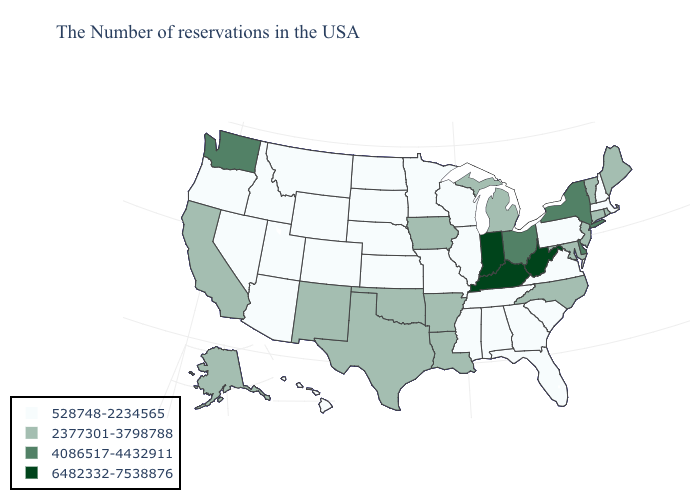How many symbols are there in the legend?
Short answer required. 4. Is the legend a continuous bar?
Write a very short answer. No. Among the states that border Missouri , does Oklahoma have the highest value?
Write a very short answer. No. Does the map have missing data?
Concise answer only. No. Which states have the lowest value in the USA?
Keep it brief. Massachusetts, New Hampshire, Pennsylvania, Virginia, South Carolina, Florida, Georgia, Alabama, Tennessee, Wisconsin, Illinois, Mississippi, Missouri, Minnesota, Kansas, Nebraska, South Dakota, North Dakota, Wyoming, Colorado, Utah, Montana, Arizona, Idaho, Nevada, Oregon, Hawaii. Which states have the highest value in the USA?
Write a very short answer. West Virginia, Kentucky, Indiana. Name the states that have a value in the range 6482332-7538876?
Be succinct. West Virginia, Kentucky, Indiana. What is the value of Louisiana?
Short answer required. 2377301-3798788. Name the states that have a value in the range 4086517-4432911?
Concise answer only. New York, Delaware, Ohio, Washington. Does Virginia have the lowest value in the USA?
Answer briefly. Yes. Which states have the highest value in the USA?
Write a very short answer. West Virginia, Kentucky, Indiana. Among the states that border Louisiana , does Arkansas have the lowest value?
Answer briefly. No. Name the states that have a value in the range 4086517-4432911?
Quick response, please. New York, Delaware, Ohio, Washington. Which states have the lowest value in the South?
Answer briefly. Virginia, South Carolina, Florida, Georgia, Alabama, Tennessee, Mississippi. Name the states that have a value in the range 6482332-7538876?
Quick response, please. West Virginia, Kentucky, Indiana. 